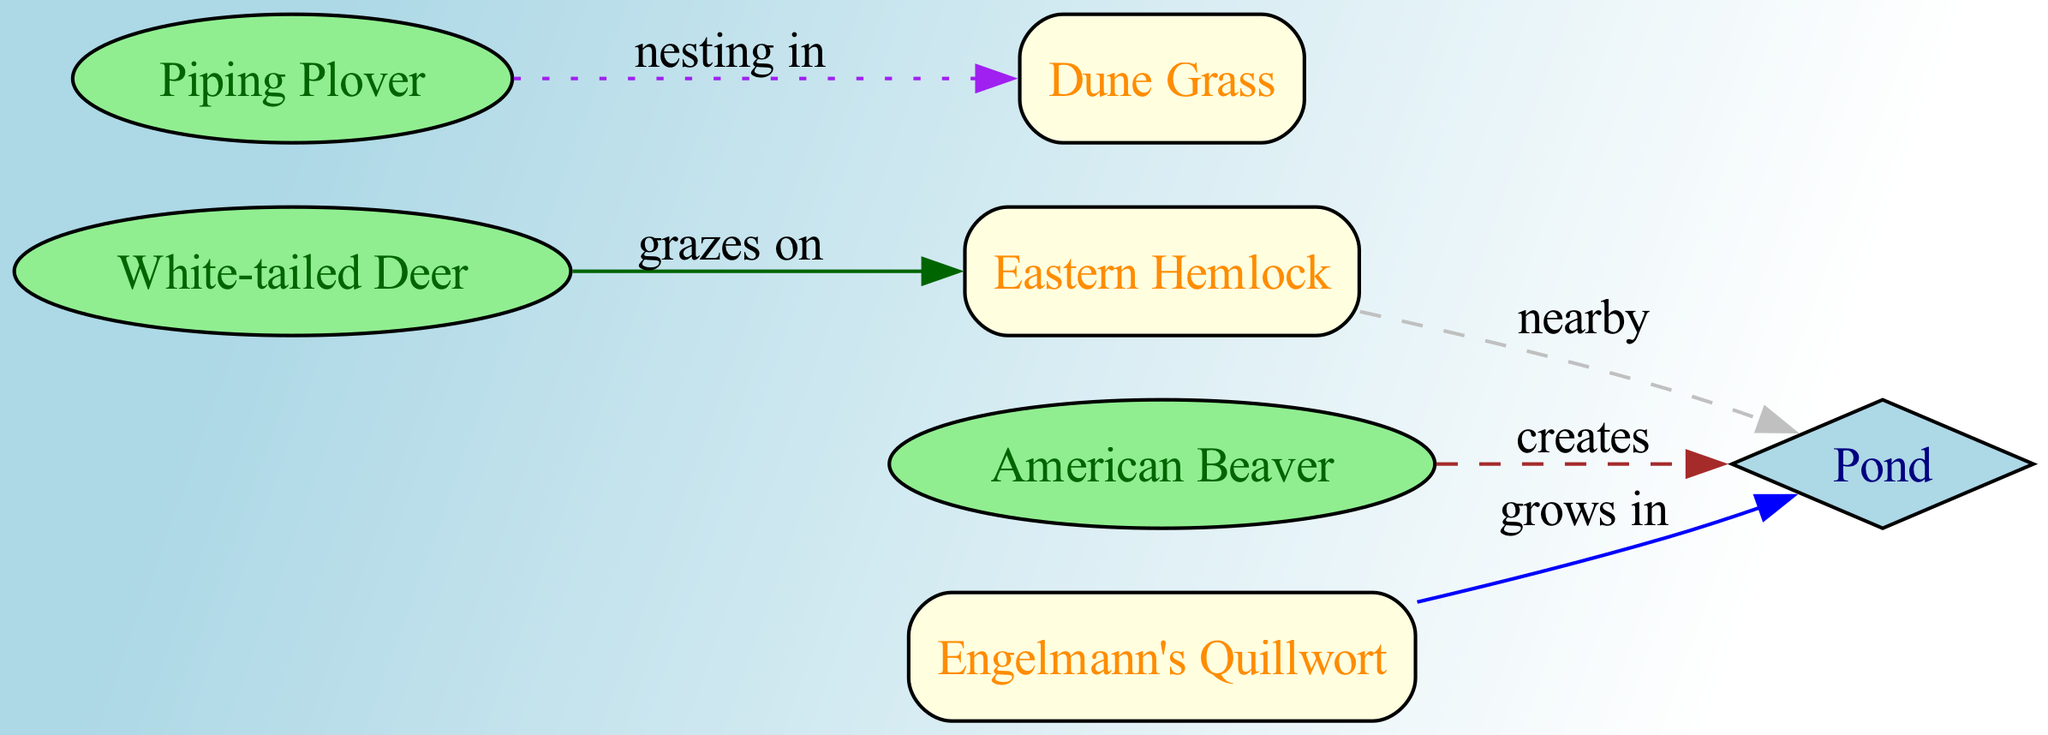What is the total number of nodes in the diagram? The diagram lists several entities that represent flora, fauna, or habitats. By counting each listed node in the provided data, we find a total of seven nodes: White-tailed Deer, Eastern Hemlock, American Beaver, Pond, Dune Grass, Piping Plover, and Engelmann's Quillwort.
Answer: 7 Which fauna grazes on Eastern Hemlock? The relationship labeled "grazes on" connects White-tailed Deer (Node 1) and Eastern Hemlock (Node 2) in the diagram. By observing this direct interaction, we verify that White-tailed Deer is the fauna of interest.
Answer: White-tailed Deer What type of interaction exists between American Beaver and Pond? The diagram illustrates that American Beaver (Node 3) "creates" Pond (Node 4) using a dashed edge, indicating an engineering interaction. Thus, the interaction type between these two nodes is "engineering."
Answer: engineering Which flora grows in habitat preference near the Pond? Engelmann's Quillwort (Node 7) is connected to Pond (Node 4) by a relationship labeled "grows in" which describes habitat preference. This leads us to conclude that Engelmann's Quillwort grows in the habitat of the Pond.
Answer: Engelmann's Quillwort How many edges are there connecting different nodes? By examining the list of edges in the data, the connections between the nodes are counted. There are five edges shown, indicating interactions between different types of nodes.
Answer: 5 What kind of relationship does Piping Plover have with Dune Grass? Piping Plover (Node 6) has a "nesting in" relationship with Dune Grass (Node 5), which is indicated by a dotted line in the diagram. This signifies that Piping Plover utilizes Dune Grass for nesting.
Answer: nesting in Which flora is consumed by White-tailed Deer? Based on the directed edge indicating "grazes on," we can see that the only flora consumed by White-tailed Deer (Node 1) is Eastern Hemlock (Node 2). A direct relationship confirms this interaction.
Answer: Eastern Hemlock How does Eastern Hemlock relate to the Pond's proximity? The diagram shows that Eastern Hemlock (Node 2) has a "nearby" relationship with Pond (Node 4), which is represented by a dashed edge. This indicates that Eastern Hemlock is close to the Pond.
Answer: nearby 